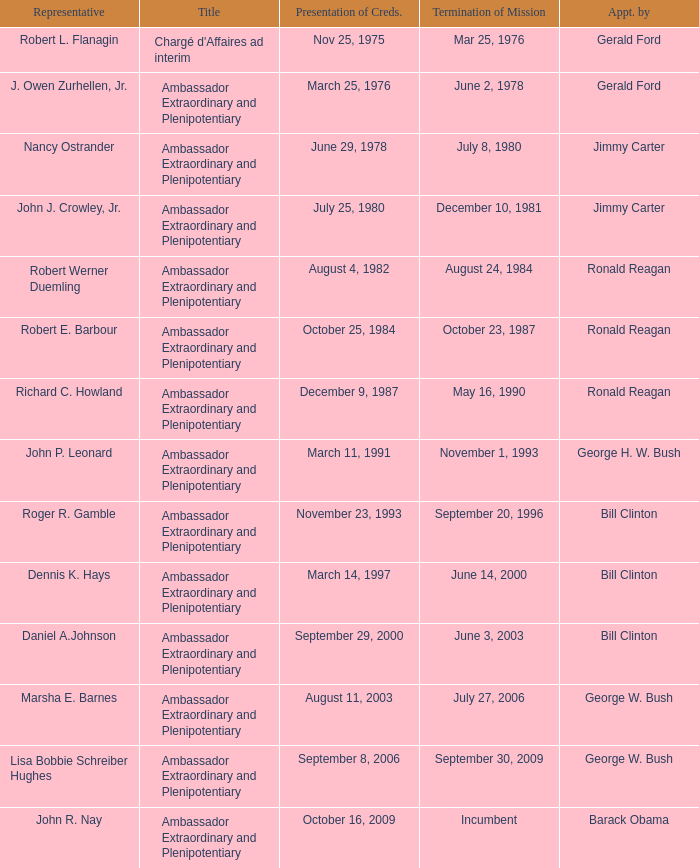What was the Termination of Mission date for the ambassador who was appointed by Barack Obama? Incumbent. 